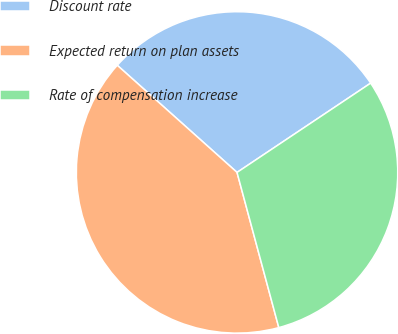Convert chart to OTSL. <chart><loc_0><loc_0><loc_500><loc_500><pie_chart><fcel>Discount rate<fcel>Expected return on plan assets<fcel>Rate of compensation increase<nl><fcel>29.01%<fcel>40.8%<fcel>30.19%<nl></chart> 